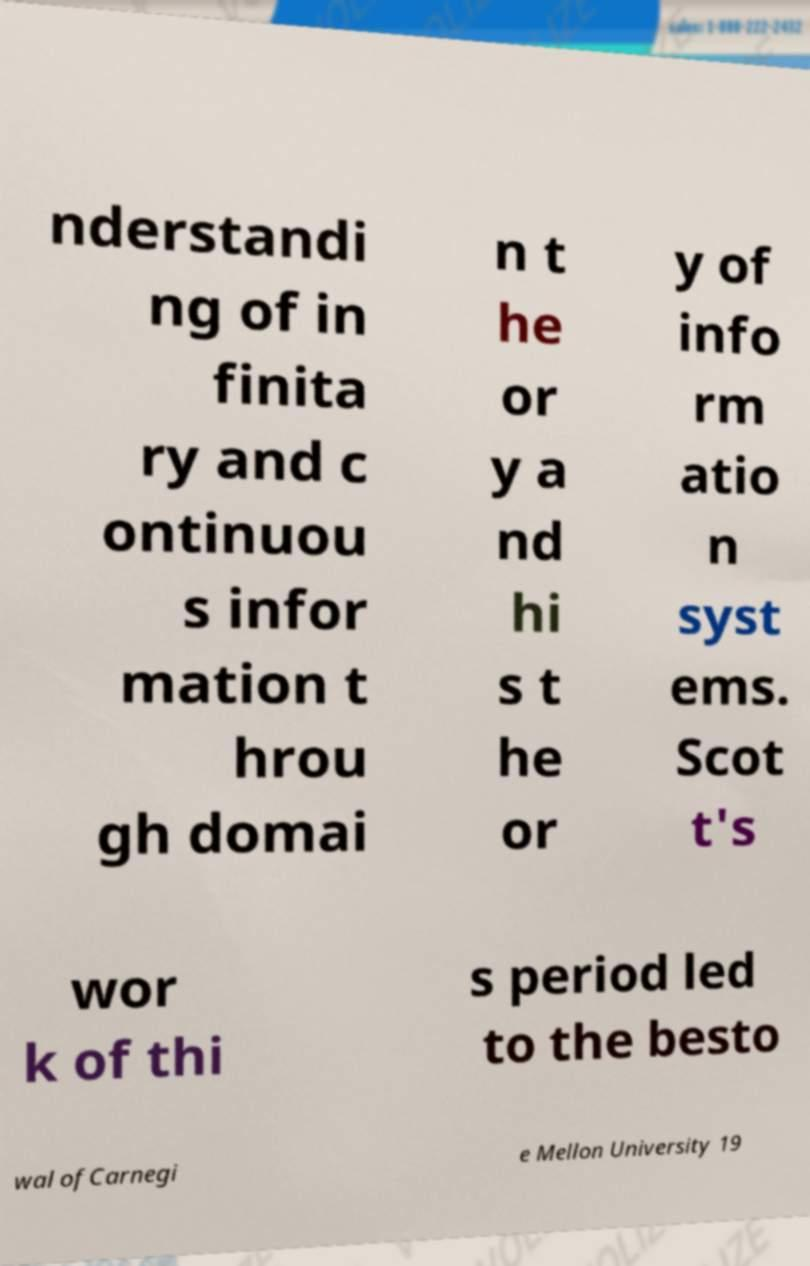Please identify and transcribe the text found in this image. nderstandi ng of in finita ry and c ontinuou s infor mation t hrou gh domai n t he or y a nd hi s t he or y of info rm atio n syst ems. Scot t's wor k of thi s period led to the besto wal ofCarnegi e Mellon University 19 